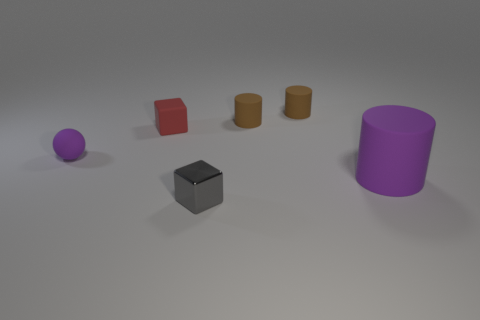Are these objects arranged in a random pattern or is there some order to their placement? The arrangement of these objects seems somewhat deliberate but not strictly ordered. They are placed with even spacing on an invisible grid, progressing from left to right with varying shapes. This distribution gives an impression of careful placement, possibly to compare and contrast the forms or to create a visually balanced composition. 